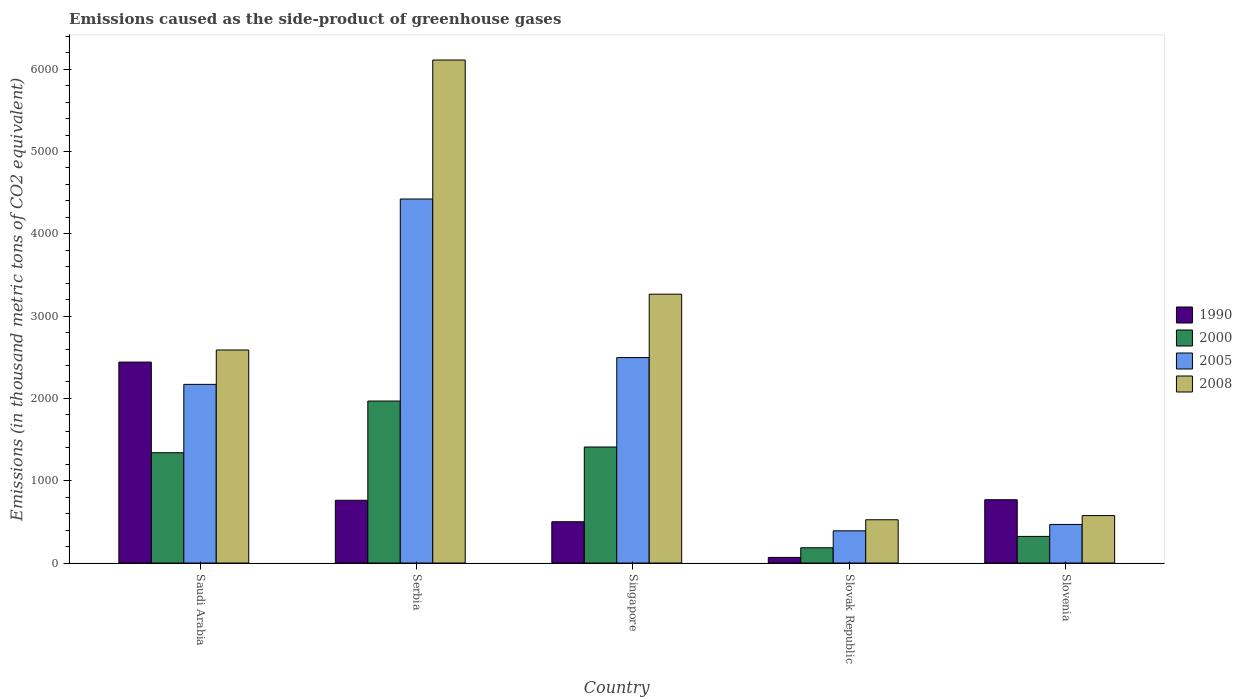How many different coloured bars are there?
Your response must be concise. 4. Are the number of bars on each tick of the X-axis equal?
Your answer should be compact. Yes. How many bars are there on the 1st tick from the left?
Your response must be concise. 4. How many bars are there on the 1st tick from the right?
Your answer should be very brief. 4. What is the label of the 2nd group of bars from the left?
Provide a succinct answer. Serbia. What is the emissions caused as the side-product of greenhouse gases in 2005 in Saudi Arabia?
Keep it short and to the point. 2170.7. Across all countries, what is the maximum emissions caused as the side-product of greenhouse gases in 2008?
Provide a short and direct response. 6111.3. Across all countries, what is the minimum emissions caused as the side-product of greenhouse gases in 2008?
Keep it short and to the point. 525.8. In which country was the emissions caused as the side-product of greenhouse gases in 2000 maximum?
Provide a short and direct response. Serbia. In which country was the emissions caused as the side-product of greenhouse gases in 1990 minimum?
Your answer should be very brief. Slovak Republic. What is the total emissions caused as the side-product of greenhouse gases in 2000 in the graph?
Offer a terse response. 5226.7. What is the difference between the emissions caused as the side-product of greenhouse gases in 2005 in Singapore and that in Slovenia?
Provide a succinct answer. 2027.5. What is the difference between the emissions caused as the side-product of greenhouse gases in 2000 in Singapore and the emissions caused as the side-product of greenhouse gases in 2005 in Serbia?
Give a very brief answer. -3013.2. What is the average emissions caused as the side-product of greenhouse gases in 2000 per country?
Offer a terse response. 1045.34. What is the difference between the emissions caused as the side-product of greenhouse gases of/in 2008 and emissions caused as the side-product of greenhouse gases of/in 1990 in Serbia?
Keep it short and to the point. 5348.9. In how many countries, is the emissions caused as the side-product of greenhouse gases in 2005 greater than 2400 thousand metric tons?
Ensure brevity in your answer.  2. What is the ratio of the emissions caused as the side-product of greenhouse gases in 2000 in Serbia to that in Singapore?
Provide a succinct answer. 1.4. Is the emissions caused as the side-product of greenhouse gases in 2000 in Saudi Arabia less than that in Serbia?
Offer a terse response. Yes. What is the difference between the highest and the second highest emissions caused as the side-product of greenhouse gases in 2000?
Provide a short and direct response. 558.5. What is the difference between the highest and the lowest emissions caused as the side-product of greenhouse gases in 2000?
Provide a short and direct response. 1782.5. What does the 2nd bar from the right in Saudi Arabia represents?
Offer a terse response. 2005. Are the values on the major ticks of Y-axis written in scientific E-notation?
Provide a short and direct response. No. Does the graph contain any zero values?
Make the answer very short. No. Where does the legend appear in the graph?
Offer a very short reply. Center right. What is the title of the graph?
Provide a succinct answer. Emissions caused as the side-product of greenhouse gases. What is the label or title of the X-axis?
Provide a short and direct response. Country. What is the label or title of the Y-axis?
Your answer should be very brief. Emissions (in thousand metric tons of CO2 equivalent). What is the Emissions (in thousand metric tons of CO2 equivalent) in 1990 in Saudi Arabia?
Provide a short and direct response. 2441.4. What is the Emissions (in thousand metric tons of CO2 equivalent) in 2000 in Saudi Arabia?
Provide a short and direct response. 1340.1. What is the Emissions (in thousand metric tons of CO2 equivalent) in 2005 in Saudi Arabia?
Offer a very short reply. 2170.7. What is the Emissions (in thousand metric tons of CO2 equivalent) in 2008 in Saudi Arabia?
Ensure brevity in your answer.  2588.3. What is the Emissions (in thousand metric tons of CO2 equivalent) of 1990 in Serbia?
Give a very brief answer. 762.4. What is the Emissions (in thousand metric tons of CO2 equivalent) in 2000 in Serbia?
Provide a succinct answer. 1968.1. What is the Emissions (in thousand metric tons of CO2 equivalent) of 2005 in Serbia?
Your response must be concise. 4422.8. What is the Emissions (in thousand metric tons of CO2 equivalent) of 2008 in Serbia?
Offer a terse response. 6111.3. What is the Emissions (in thousand metric tons of CO2 equivalent) of 1990 in Singapore?
Your answer should be compact. 501.5. What is the Emissions (in thousand metric tons of CO2 equivalent) of 2000 in Singapore?
Provide a succinct answer. 1409.6. What is the Emissions (in thousand metric tons of CO2 equivalent) of 2005 in Singapore?
Offer a very short reply. 2496.4. What is the Emissions (in thousand metric tons of CO2 equivalent) in 2008 in Singapore?
Your response must be concise. 3266.4. What is the Emissions (in thousand metric tons of CO2 equivalent) of 1990 in Slovak Republic?
Keep it short and to the point. 68.3. What is the Emissions (in thousand metric tons of CO2 equivalent) of 2000 in Slovak Republic?
Ensure brevity in your answer.  185.6. What is the Emissions (in thousand metric tons of CO2 equivalent) in 2005 in Slovak Republic?
Provide a succinct answer. 391.3. What is the Emissions (in thousand metric tons of CO2 equivalent) of 2008 in Slovak Republic?
Offer a very short reply. 525.8. What is the Emissions (in thousand metric tons of CO2 equivalent) of 1990 in Slovenia?
Your answer should be compact. 769. What is the Emissions (in thousand metric tons of CO2 equivalent) of 2000 in Slovenia?
Your answer should be compact. 323.3. What is the Emissions (in thousand metric tons of CO2 equivalent) of 2005 in Slovenia?
Provide a succinct answer. 468.9. What is the Emissions (in thousand metric tons of CO2 equivalent) of 2008 in Slovenia?
Provide a succinct answer. 576.7. Across all countries, what is the maximum Emissions (in thousand metric tons of CO2 equivalent) in 1990?
Give a very brief answer. 2441.4. Across all countries, what is the maximum Emissions (in thousand metric tons of CO2 equivalent) in 2000?
Provide a short and direct response. 1968.1. Across all countries, what is the maximum Emissions (in thousand metric tons of CO2 equivalent) of 2005?
Provide a short and direct response. 4422.8. Across all countries, what is the maximum Emissions (in thousand metric tons of CO2 equivalent) in 2008?
Your answer should be very brief. 6111.3. Across all countries, what is the minimum Emissions (in thousand metric tons of CO2 equivalent) in 1990?
Provide a short and direct response. 68.3. Across all countries, what is the minimum Emissions (in thousand metric tons of CO2 equivalent) in 2000?
Your answer should be compact. 185.6. Across all countries, what is the minimum Emissions (in thousand metric tons of CO2 equivalent) of 2005?
Give a very brief answer. 391.3. Across all countries, what is the minimum Emissions (in thousand metric tons of CO2 equivalent) of 2008?
Offer a terse response. 525.8. What is the total Emissions (in thousand metric tons of CO2 equivalent) of 1990 in the graph?
Keep it short and to the point. 4542.6. What is the total Emissions (in thousand metric tons of CO2 equivalent) in 2000 in the graph?
Keep it short and to the point. 5226.7. What is the total Emissions (in thousand metric tons of CO2 equivalent) of 2005 in the graph?
Provide a short and direct response. 9950.1. What is the total Emissions (in thousand metric tons of CO2 equivalent) of 2008 in the graph?
Keep it short and to the point. 1.31e+04. What is the difference between the Emissions (in thousand metric tons of CO2 equivalent) in 1990 in Saudi Arabia and that in Serbia?
Ensure brevity in your answer.  1679. What is the difference between the Emissions (in thousand metric tons of CO2 equivalent) in 2000 in Saudi Arabia and that in Serbia?
Ensure brevity in your answer.  -628. What is the difference between the Emissions (in thousand metric tons of CO2 equivalent) of 2005 in Saudi Arabia and that in Serbia?
Give a very brief answer. -2252.1. What is the difference between the Emissions (in thousand metric tons of CO2 equivalent) of 2008 in Saudi Arabia and that in Serbia?
Make the answer very short. -3523. What is the difference between the Emissions (in thousand metric tons of CO2 equivalent) of 1990 in Saudi Arabia and that in Singapore?
Your answer should be very brief. 1939.9. What is the difference between the Emissions (in thousand metric tons of CO2 equivalent) of 2000 in Saudi Arabia and that in Singapore?
Offer a terse response. -69.5. What is the difference between the Emissions (in thousand metric tons of CO2 equivalent) of 2005 in Saudi Arabia and that in Singapore?
Provide a succinct answer. -325.7. What is the difference between the Emissions (in thousand metric tons of CO2 equivalent) of 2008 in Saudi Arabia and that in Singapore?
Your response must be concise. -678.1. What is the difference between the Emissions (in thousand metric tons of CO2 equivalent) in 1990 in Saudi Arabia and that in Slovak Republic?
Ensure brevity in your answer.  2373.1. What is the difference between the Emissions (in thousand metric tons of CO2 equivalent) in 2000 in Saudi Arabia and that in Slovak Republic?
Your answer should be compact. 1154.5. What is the difference between the Emissions (in thousand metric tons of CO2 equivalent) in 2005 in Saudi Arabia and that in Slovak Republic?
Your answer should be compact. 1779.4. What is the difference between the Emissions (in thousand metric tons of CO2 equivalent) of 2008 in Saudi Arabia and that in Slovak Republic?
Provide a succinct answer. 2062.5. What is the difference between the Emissions (in thousand metric tons of CO2 equivalent) in 1990 in Saudi Arabia and that in Slovenia?
Make the answer very short. 1672.4. What is the difference between the Emissions (in thousand metric tons of CO2 equivalent) of 2000 in Saudi Arabia and that in Slovenia?
Ensure brevity in your answer.  1016.8. What is the difference between the Emissions (in thousand metric tons of CO2 equivalent) of 2005 in Saudi Arabia and that in Slovenia?
Your answer should be very brief. 1701.8. What is the difference between the Emissions (in thousand metric tons of CO2 equivalent) of 2008 in Saudi Arabia and that in Slovenia?
Offer a very short reply. 2011.6. What is the difference between the Emissions (in thousand metric tons of CO2 equivalent) in 1990 in Serbia and that in Singapore?
Your answer should be very brief. 260.9. What is the difference between the Emissions (in thousand metric tons of CO2 equivalent) in 2000 in Serbia and that in Singapore?
Offer a terse response. 558.5. What is the difference between the Emissions (in thousand metric tons of CO2 equivalent) in 2005 in Serbia and that in Singapore?
Your answer should be compact. 1926.4. What is the difference between the Emissions (in thousand metric tons of CO2 equivalent) in 2008 in Serbia and that in Singapore?
Provide a succinct answer. 2844.9. What is the difference between the Emissions (in thousand metric tons of CO2 equivalent) in 1990 in Serbia and that in Slovak Republic?
Your answer should be very brief. 694.1. What is the difference between the Emissions (in thousand metric tons of CO2 equivalent) in 2000 in Serbia and that in Slovak Republic?
Give a very brief answer. 1782.5. What is the difference between the Emissions (in thousand metric tons of CO2 equivalent) in 2005 in Serbia and that in Slovak Republic?
Ensure brevity in your answer.  4031.5. What is the difference between the Emissions (in thousand metric tons of CO2 equivalent) in 2008 in Serbia and that in Slovak Republic?
Give a very brief answer. 5585.5. What is the difference between the Emissions (in thousand metric tons of CO2 equivalent) in 2000 in Serbia and that in Slovenia?
Provide a short and direct response. 1644.8. What is the difference between the Emissions (in thousand metric tons of CO2 equivalent) in 2005 in Serbia and that in Slovenia?
Your answer should be very brief. 3953.9. What is the difference between the Emissions (in thousand metric tons of CO2 equivalent) in 2008 in Serbia and that in Slovenia?
Give a very brief answer. 5534.6. What is the difference between the Emissions (in thousand metric tons of CO2 equivalent) of 1990 in Singapore and that in Slovak Republic?
Your answer should be compact. 433.2. What is the difference between the Emissions (in thousand metric tons of CO2 equivalent) in 2000 in Singapore and that in Slovak Republic?
Your response must be concise. 1224. What is the difference between the Emissions (in thousand metric tons of CO2 equivalent) of 2005 in Singapore and that in Slovak Republic?
Keep it short and to the point. 2105.1. What is the difference between the Emissions (in thousand metric tons of CO2 equivalent) in 2008 in Singapore and that in Slovak Republic?
Provide a succinct answer. 2740.6. What is the difference between the Emissions (in thousand metric tons of CO2 equivalent) of 1990 in Singapore and that in Slovenia?
Keep it short and to the point. -267.5. What is the difference between the Emissions (in thousand metric tons of CO2 equivalent) of 2000 in Singapore and that in Slovenia?
Your response must be concise. 1086.3. What is the difference between the Emissions (in thousand metric tons of CO2 equivalent) in 2005 in Singapore and that in Slovenia?
Keep it short and to the point. 2027.5. What is the difference between the Emissions (in thousand metric tons of CO2 equivalent) in 2008 in Singapore and that in Slovenia?
Offer a terse response. 2689.7. What is the difference between the Emissions (in thousand metric tons of CO2 equivalent) in 1990 in Slovak Republic and that in Slovenia?
Give a very brief answer. -700.7. What is the difference between the Emissions (in thousand metric tons of CO2 equivalent) of 2000 in Slovak Republic and that in Slovenia?
Your answer should be very brief. -137.7. What is the difference between the Emissions (in thousand metric tons of CO2 equivalent) in 2005 in Slovak Republic and that in Slovenia?
Provide a succinct answer. -77.6. What is the difference between the Emissions (in thousand metric tons of CO2 equivalent) of 2008 in Slovak Republic and that in Slovenia?
Give a very brief answer. -50.9. What is the difference between the Emissions (in thousand metric tons of CO2 equivalent) of 1990 in Saudi Arabia and the Emissions (in thousand metric tons of CO2 equivalent) of 2000 in Serbia?
Your answer should be compact. 473.3. What is the difference between the Emissions (in thousand metric tons of CO2 equivalent) in 1990 in Saudi Arabia and the Emissions (in thousand metric tons of CO2 equivalent) in 2005 in Serbia?
Your answer should be very brief. -1981.4. What is the difference between the Emissions (in thousand metric tons of CO2 equivalent) in 1990 in Saudi Arabia and the Emissions (in thousand metric tons of CO2 equivalent) in 2008 in Serbia?
Your response must be concise. -3669.9. What is the difference between the Emissions (in thousand metric tons of CO2 equivalent) of 2000 in Saudi Arabia and the Emissions (in thousand metric tons of CO2 equivalent) of 2005 in Serbia?
Offer a terse response. -3082.7. What is the difference between the Emissions (in thousand metric tons of CO2 equivalent) of 2000 in Saudi Arabia and the Emissions (in thousand metric tons of CO2 equivalent) of 2008 in Serbia?
Your answer should be compact. -4771.2. What is the difference between the Emissions (in thousand metric tons of CO2 equivalent) of 2005 in Saudi Arabia and the Emissions (in thousand metric tons of CO2 equivalent) of 2008 in Serbia?
Provide a succinct answer. -3940.6. What is the difference between the Emissions (in thousand metric tons of CO2 equivalent) in 1990 in Saudi Arabia and the Emissions (in thousand metric tons of CO2 equivalent) in 2000 in Singapore?
Make the answer very short. 1031.8. What is the difference between the Emissions (in thousand metric tons of CO2 equivalent) of 1990 in Saudi Arabia and the Emissions (in thousand metric tons of CO2 equivalent) of 2005 in Singapore?
Offer a very short reply. -55. What is the difference between the Emissions (in thousand metric tons of CO2 equivalent) in 1990 in Saudi Arabia and the Emissions (in thousand metric tons of CO2 equivalent) in 2008 in Singapore?
Offer a terse response. -825. What is the difference between the Emissions (in thousand metric tons of CO2 equivalent) in 2000 in Saudi Arabia and the Emissions (in thousand metric tons of CO2 equivalent) in 2005 in Singapore?
Provide a succinct answer. -1156.3. What is the difference between the Emissions (in thousand metric tons of CO2 equivalent) in 2000 in Saudi Arabia and the Emissions (in thousand metric tons of CO2 equivalent) in 2008 in Singapore?
Give a very brief answer. -1926.3. What is the difference between the Emissions (in thousand metric tons of CO2 equivalent) of 2005 in Saudi Arabia and the Emissions (in thousand metric tons of CO2 equivalent) of 2008 in Singapore?
Ensure brevity in your answer.  -1095.7. What is the difference between the Emissions (in thousand metric tons of CO2 equivalent) of 1990 in Saudi Arabia and the Emissions (in thousand metric tons of CO2 equivalent) of 2000 in Slovak Republic?
Make the answer very short. 2255.8. What is the difference between the Emissions (in thousand metric tons of CO2 equivalent) of 1990 in Saudi Arabia and the Emissions (in thousand metric tons of CO2 equivalent) of 2005 in Slovak Republic?
Offer a very short reply. 2050.1. What is the difference between the Emissions (in thousand metric tons of CO2 equivalent) in 1990 in Saudi Arabia and the Emissions (in thousand metric tons of CO2 equivalent) in 2008 in Slovak Republic?
Offer a very short reply. 1915.6. What is the difference between the Emissions (in thousand metric tons of CO2 equivalent) of 2000 in Saudi Arabia and the Emissions (in thousand metric tons of CO2 equivalent) of 2005 in Slovak Republic?
Your answer should be compact. 948.8. What is the difference between the Emissions (in thousand metric tons of CO2 equivalent) in 2000 in Saudi Arabia and the Emissions (in thousand metric tons of CO2 equivalent) in 2008 in Slovak Republic?
Offer a very short reply. 814.3. What is the difference between the Emissions (in thousand metric tons of CO2 equivalent) of 2005 in Saudi Arabia and the Emissions (in thousand metric tons of CO2 equivalent) of 2008 in Slovak Republic?
Give a very brief answer. 1644.9. What is the difference between the Emissions (in thousand metric tons of CO2 equivalent) of 1990 in Saudi Arabia and the Emissions (in thousand metric tons of CO2 equivalent) of 2000 in Slovenia?
Offer a terse response. 2118.1. What is the difference between the Emissions (in thousand metric tons of CO2 equivalent) of 1990 in Saudi Arabia and the Emissions (in thousand metric tons of CO2 equivalent) of 2005 in Slovenia?
Keep it short and to the point. 1972.5. What is the difference between the Emissions (in thousand metric tons of CO2 equivalent) of 1990 in Saudi Arabia and the Emissions (in thousand metric tons of CO2 equivalent) of 2008 in Slovenia?
Make the answer very short. 1864.7. What is the difference between the Emissions (in thousand metric tons of CO2 equivalent) of 2000 in Saudi Arabia and the Emissions (in thousand metric tons of CO2 equivalent) of 2005 in Slovenia?
Make the answer very short. 871.2. What is the difference between the Emissions (in thousand metric tons of CO2 equivalent) in 2000 in Saudi Arabia and the Emissions (in thousand metric tons of CO2 equivalent) in 2008 in Slovenia?
Your answer should be compact. 763.4. What is the difference between the Emissions (in thousand metric tons of CO2 equivalent) of 2005 in Saudi Arabia and the Emissions (in thousand metric tons of CO2 equivalent) of 2008 in Slovenia?
Offer a terse response. 1594. What is the difference between the Emissions (in thousand metric tons of CO2 equivalent) of 1990 in Serbia and the Emissions (in thousand metric tons of CO2 equivalent) of 2000 in Singapore?
Offer a very short reply. -647.2. What is the difference between the Emissions (in thousand metric tons of CO2 equivalent) in 1990 in Serbia and the Emissions (in thousand metric tons of CO2 equivalent) in 2005 in Singapore?
Offer a very short reply. -1734. What is the difference between the Emissions (in thousand metric tons of CO2 equivalent) of 1990 in Serbia and the Emissions (in thousand metric tons of CO2 equivalent) of 2008 in Singapore?
Provide a short and direct response. -2504. What is the difference between the Emissions (in thousand metric tons of CO2 equivalent) in 2000 in Serbia and the Emissions (in thousand metric tons of CO2 equivalent) in 2005 in Singapore?
Provide a succinct answer. -528.3. What is the difference between the Emissions (in thousand metric tons of CO2 equivalent) of 2000 in Serbia and the Emissions (in thousand metric tons of CO2 equivalent) of 2008 in Singapore?
Your answer should be very brief. -1298.3. What is the difference between the Emissions (in thousand metric tons of CO2 equivalent) in 2005 in Serbia and the Emissions (in thousand metric tons of CO2 equivalent) in 2008 in Singapore?
Your answer should be compact. 1156.4. What is the difference between the Emissions (in thousand metric tons of CO2 equivalent) in 1990 in Serbia and the Emissions (in thousand metric tons of CO2 equivalent) in 2000 in Slovak Republic?
Offer a very short reply. 576.8. What is the difference between the Emissions (in thousand metric tons of CO2 equivalent) of 1990 in Serbia and the Emissions (in thousand metric tons of CO2 equivalent) of 2005 in Slovak Republic?
Make the answer very short. 371.1. What is the difference between the Emissions (in thousand metric tons of CO2 equivalent) in 1990 in Serbia and the Emissions (in thousand metric tons of CO2 equivalent) in 2008 in Slovak Republic?
Offer a very short reply. 236.6. What is the difference between the Emissions (in thousand metric tons of CO2 equivalent) of 2000 in Serbia and the Emissions (in thousand metric tons of CO2 equivalent) of 2005 in Slovak Republic?
Your answer should be very brief. 1576.8. What is the difference between the Emissions (in thousand metric tons of CO2 equivalent) in 2000 in Serbia and the Emissions (in thousand metric tons of CO2 equivalent) in 2008 in Slovak Republic?
Provide a succinct answer. 1442.3. What is the difference between the Emissions (in thousand metric tons of CO2 equivalent) in 2005 in Serbia and the Emissions (in thousand metric tons of CO2 equivalent) in 2008 in Slovak Republic?
Keep it short and to the point. 3897. What is the difference between the Emissions (in thousand metric tons of CO2 equivalent) of 1990 in Serbia and the Emissions (in thousand metric tons of CO2 equivalent) of 2000 in Slovenia?
Offer a terse response. 439.1. What is the difference between the Emissions (in thousand metric tons of CO2 equivalent) of 1990 in Serbia and the Emissions (in thousand metric tons of CO2 equivalent) of 2005 in Slovenia?
Your answer should be very brief. 293.5. What is the difference between the Emissions (in thousand metric tons of CO2 equivalent) in 1990 in Serbia and the Emissions (in thousand metric tons of CO2 equivalent) in 2008 in Slovenia?
Your answer should be very brief. 185.7. What is the difference between the Emissions (in thousand metric tons of CO2 equivalent) in 2000 in Serbia and the Emissions (in thousand metric tons of CO2 equivalent) in 2005 in Slovenia?
Ensure brevity in your answer.  1499.2. What is the difference between the Emissions (in thousand metric tons of CO2 equivalent) in 2000 in Serbia and the Emissions (in thousand metric tons of CO2 equivalent) in 2008 in Slovenia?
Offer a very short reply. 1391.4. What is the difference between the Emissions (in thousand metric tons of CO2 equivalent) of 2005 in Serbia and the Emissions (in thousand metric tons of CO2 equivalent) of 2008 in Slovenia?
Make the answer very short. 3846.1. What is the difference between the Emissions (in thousand metric tons of CO2 equivalent) of 1990 in Singapore and the Emissions (in thousand metric tons of CO2 equivalent) of 2000 in Slovak Republic?
Keep it short and to the point. 315.9. What is the difference between the Emissions (in thousand metric tons of CO2 equivalent) in 1990 in Singapore and the Emissions (in thousand metric tons of CO2 equivalent) in 2005 in Slovak Republic?
Your answer should be very brief. 110.2. What is the difference between the Emissions (in thousand metric tons of CO2 equivalent) of 1990 in Singapore and the Emissions (in thousand metric tons of CO2 equivalent) of 2008 in Slovak Republic?
Provide a short and direct response. -24.3. What is the difference between the Emissions (in thousand metric tons of CO2 equivalent) of 2000 in Singapore and the Emissions (in thousand metric tons of CO2 equivalent) of 2005 in Slovak Republic?
Ensure brevity in your answer.  1018.3. What is the difference between the Emissions (in thousand metric tons of CO2 equivalent) in 2000 in Singapore and the Emissions (in thousand metric tons of CO2 equivalent) in 2008 in Slovak Republic?
Offer a very short reply. 883.8. What is the difference between the Emissions (in thousand metric tons of CO2 equivalent) in 2005 in Singapore and the Emissions (in thousand metric tons of CO2 equivalent) in 2008 in Slovak Republic?
Your response must be concise. 1970.6. What is the difference between the Emissions (in thousand metric tons of CO2 equivalent) of 1990 in Singapore and the Emissions (in thousand metric tons of CO2 equivalent) of 2000 in Slovenia?
Give a very brief answer. 178.2. What is the difference between the Emissions (in thousand metric tons of CO2 equivalent) of 1990 in Singapore and the Emissions (in thousand metric tons of CO2 equivalent) of 2005 in Slovenia?
Offer a very short reply. 32.6. What is the difference between the Emissions (in thousand metric tons of CO2 equivalent) in 1990 in Singapore and the Emissions (in thousand metric tons of CO2 equivalent) in 2008 in Slovenia?
Make the answer very short. -75.2. What is the difference between the Emissions (in thousand metric tons of CO2 equivalent) of 2000 in Singapore and the Emissions (in thousand metric tons of CO2 equivalent) of 2005 in Slovenia?
Your answer should be very brief. 940.7. What is the difference between the Emissions (in thousand metric tons of CO2 equivalent) in 2000 in Singapore and the Emissions (in thousand metric tons of CO2 equivalent) in 2008 in Slovenia?
Keep it short and to the point. 832.9. What is the difference between the Emissions (in thousand metric tons of CO2 equivalent) of 2005 in Singapore and the Emissions (in thousand metric tons of CO2 equivalent) of 2008 in Slovenia?
Offer a very short reply. 1919.7. What is the difference between the Emissions (in thousand metric tons of CO2 equivalent) in 1990 in Slovak Republic and the Emissions (in thousand metric tons of CO2 equivalent) in 2000 in Slovenia?
Give a very brief answer. -255. What is the difference between the Emissions (in thousand metric tons of CO2 equivalent) in 1990 in Slovak Republic and the Emissions (in thousand metric tons of CO2 equivalent) in 2005 in Slovenia?
Your response must be concise. -400.6. What is the difference between the Emissions (in thousand metric tons of CO2 equivalent) in 1990 in Slovak Republic and the Emissions (in thousand metric tons of CO2 equivalent) in 2008 in Slovenia?
Ensure brevity in your answer.  -508.4. What is the difference between the Emissions (in thousand metric tons of CO2 equivalent) of 2000 in Slovak Republic and the Emissions (in thousand metric tons of CO2 equivalent) of 2005 in Slovenia?
Your answer should be very brief. -283.3. What is the difference between the Emissions (in thousand metric tons of CO2 equivalent) in 2000 in Slovak Republic and the Emissions (in thousand metric tons of CO2 equivalent) in 2008 in Slovenia?
Your answer should be very brief. -391.1. What is the difference between the Emissions (in thousand metric tons of CO2 equivalent) in 2005 in Slovak Republic and the Emissions (in thousand metric tons of CO2 equivalent) in 2008 in Slovenia?
Ensure brevity in your answer.  -185.4. What is the average Emissions (in thousand metric tons of CO2 equivalent) of 1990 per country?
Your answer should be compact. 908.52. What is the average Emissions (in thousand metric tons of CO2 equivalent) in 2000 per country?
Your answer should be compact. 1045.34. What is the average Emissions (in thousand metric tons of CO2 equivalent) of 2005 per country?
Provide a short and direct response. 1990.02. What is the average Emissions (in thousand metric tons of CO2 equivalent) in 2008 per country?
Your response must be concise. 2613.7. What is the difference between the Emissions (in thousand metric tons of CO2 equivalent) of 1990 and Emissions (in thousand metric tons of CO2 equivalent) of 2000 in Saudi Arabia?
Give a very brief answer. 1101.3. What is the difference between the Emissions (in thousand metric tons of CO2 equivalent) in 1990 and Emissions (in thousand metric tons of CO2 equivalent) in 2005 in Saudi Arabia?
Provide a succinct answer. 270.7. What is the difference between the Emissions (in thousand metric tons of CO2 equivalent) of 1990 and Emissions (in thousand metric tons of CO2 equivalent) of 2008 in Saudi Arabia?
Make the answer very short. -146.9. What is the difference between the Emissions (in thousand metric tons of CO2 equivalent) in 2000 and Emissions (in thousand metric tons of CO2 equivalent) in 2005 in Saudi Arabia?
Your response must be concise. -830.6. What is the difference between the Emissions (in thousand metric tons of CO2 equivalent) of 2000 and Emissions (in thousand metric tons of CO2 equivalent) of 2008 in Saudi Arabia?
Ensure brevity in your answer.  -1248.2. What is the difference between the Emissions (in thousand metric tons of CO2 equivalent) in 2005 and Emissions (in thousand metric tons of CO2 equivalent) in 2008 in Saudi Arabia?
Make the answer very short. -417.6. What is the difference between the Emissions (in thousand metric tons of CO2 equivalent) in 1990 and Emissions (in thousand metric tons of CO2 equivalent) in 2000 in Serbia?
Your answer should be very brief. -1205.7. What is the difference between the Emissions (in thousand metric tons of CO2 equivalent) in 1990 and Emissions (in thousand metric tons of CO2 equivalent) in 2005 in Serbia?
Provide a short and direct response. -3660.4. What is the difference between the Emissions (in thousand metric tons of CO2 equivalent) in 1990 and Emissions (in thousand metric tons of CO2 equivalent) in 2008 in Serbia?
Ensure brevity in your answer.  -5348.9. What is the difference between the Emissions (in thousand metric tons of CO2 equivalent) in 2000 and Emissions (in thousand metric tons of CO2 equivalent) in 2005 in Serbia?
Ensure brevity in your answer.  -2454.7. What is the difference between the Emissions (in thousand metric tons of CO2 equivalent) in 2000 and Emissions (in thousand metric tons of CO2 equivalent) in 2008 in Serbia?
Your response must be concise. -4143.2. What is the difference between the Emissions (in thousand metric tons of CO2 equivalent) of 2005 and Emissions (in thousand metric tons of CO2 equivalent) of 2008 in Serbia?
Your response must be concise. -1688.5. What is the difference between the Emissions (in thousand metric tons of CO2 equivalent) in 1990 and Emissions (in thousand metric tons of CO2 equivalent) in 2000 in Singapore?
Offer a very short reply. -908.1. What is the difference between the Emissions (in thousand metric tons of CO2 equivalent) of 1990 and Emissions (in thousand metric tons of CO2 equivalent) of 2005 in Singapore?
Offer a very short reply. -1994.9. What is the difference between the Emissions (in thousand metric tons of CO2 equivalent) of 1990 and Emissions (in thousand metric tons of CO2 equivalent) of 2008 in Singapore?
Provide a succinct answer. -2764.9. What is the difference between the Emissions (in thousand metric tons of CO2 equivalent) in 2000 and Emissions (in thousand metric tons of CO2 equivalent) in 2005 in Singapore?
Give a very brief answer. -1086.8. What is the difference between the Emissions (in thousand metric tons of CO2 equivalent) of 2000 and Emissions (in thousand metric tons of CO2 equivalent) of 2008 in Singapore?
Offer a very short reply. -1856.8. What is the difference between the Emissions (in thousand metric tons of CO2 equivalent) of 2005 and Emissions (in thousand metric tons of CO2 equivalent) of 2008 in Singapore?
Your answer should be very brief. -770. What is the difference between the Emissions (in thousand metric tons of CO2 equivalent) of 1990 and Emissions (in thousand metric tons of CO2 equivalent) of 2000 in Slovak Republic?
Your answer should be compact. -117.3. What is the difference between the Emissions (in thousand metric tons of CO2 equivalent) in 1990 and Emissions (in thousand metric tons of CO2 equivalent) in 2005 in Slovak Republic?
Give a very brief answer. -323. What is the difference between the Emissions (in thousand metric tons of CO2 equivalent) of 1990 and Emissions (in thousand metric tons of CO2 equivalent) of 2008 in Slovak Republic?
Your answer should be compact. -457.5. What is the difference between the Emissions (in thousand metric tons of CO2 equivalent) in 2000 and Emissions (in thousand metric tons of CO2 equivalent) in 2005 in Slovak Republic?
Give a very brief answer. -205.7. What is the difference between the Emissions (in thousand metric tons of CO2 equivalent) in 2000 and Emissions (in thousand metric tons of CO2 equivalent) in 2008 in Slovak Republic?
Offer a very short reply. -340.2. What is the difference between the Emissions (in thousand metric tons of CO2 equivalent) in 2005 and Emissions (in thousand metric tons of CO2 equivalent) in 2008 in Slovak Republic?
Provide a short and direct response. -134.5. What is the difference between the Emissions (in thousand metric tons of CO2 equivalent) in 1990 and Emissions (in thousand metric tons of CO2 equivalent) in 2000 in Slovenia?
Provide a short and direct response. 445.7. What is the difference between the Emissions (in thousand metric tons of CO2 equivalent) of 1990 and Emissions (in thousand metric tons of CO2 equivalent) of 2005 in Slovenia?
Your answer should be compact. 300.1. What is the difference between the Emissions (in thousand metric tons of CO2 equivalent) in 1990 and Emissions (in thousand metric tons of CO2 equivalent) in 2008 in Slovenia?
Keep it short and to the point. 192.3. What is the difference between the Emissions (in thousand metric tons of CO2 equivalent) of 2000 and Emissions (in thousand metric tons of CO2 equivalent) of 2005 in Slovenia?
Give a very brief answer. -145.6. What is the difference between the Emissions (in thousand metric tons of CO2 equivalent) in 2000 and Emissions (in thousand metric tons of CO2 equivalent) in 2008 in Slovenia?
Give a very brief answer. -253.4. What is the difference between the Emissions (in thousand metric tons of CO2 equivalent) of 2005 and Emissions (in thousand metric tons of CO2 equivalent) of 2008 in Slovenia?
Ensure brevity in your answer.  -107.8. What is the ratio of the Emissions (in thousand metric tons of CO2 equivalent) of 1990 in Saudi Arabia to that in Serbia?
Provide a succinct answer. 3.2. What is the ratio of the Emissions (in thousand metric tons of CO2 equivalent) of 2000 in Saudi Arabia to that in Serbia?
Ensure brevity in your answer.  0.68. What is the ratio of the Emissions (in thousand metric tons of CO2 equivalent) in 2005 in Saudi Arabia to that in Serbia?
Make the answer very short. 0.49. What is the ratio of the Emissions (in thousand metric tons of CO2 equivalent) of 2008 in Saudi Arabia to that in Serbia?
Provide a short and direct response. 0.42. What is the ratio of the Emissions (in thousand metric tons of CO2 equivalent) in 1990 in Saudi Arabia to that in Singapore?
Keep it short and to the point. 4.87. What is the ratio of the Emissions (in thousand metric tons of CO2 equivalent) in 2000 in Saudi Arabia to that in Singapore?
Make the answer very short. 0.95. What is the ratio of the Emissions (in thousand metric tons of CO2 equivalent) of 2005 in Saudi Arabia to that in Singapore?
Provide a short and direct response. 0.87. What is the ratio of the Emissions (in thousand metric tons of CO2 equivalent) in 2008 in Saudi Arabia to that in Singapore?
Your answer should be very brief. 0.79. What is the ratio of the Emissions (in thousand metric tons of CO2 equivalent) in 1990 in Saudi Arabia to that in Slovak Republic?
Your response must be concise. 35.75. What is the ratio of the Emissions (in thousand metric tons of CO2 equivalent) of 2000 in Saudi Arabia to that in Slovak Republic?
Give a very brief answer. 7.22. What is the ratio of the Emissions (in thousand metric tons of CO2 equivalent) of 2005 in Saudi Arabia to that in Slovak Republic?
Your answer should be compact. 5.55. What is the ratio of the Emissions (in thousand metric tons of CO2 equivalent) in 2008 in Saudi Arabia to that in Slovak Republic?
Your answer should be compact. 4.92. What is the ratio of the Emissions (in thousand metric tons of CO2 equivalent) of 1990 in Saudi Arabia to that in Slovenia?
Provide a succinct answer. 3.17. What is the ratio of the Emissions (in thousand metric tons of CO2 equivalent) of 2000 in Saudi Arabia to that in Slovenia?
Your answer should be very brief. 4.15. What is the ratio of the Emissions (in thousand metric tons of CO2 equivalent) in 2005 in Saudi Arabia to that in Slovenia?
Provide a short and direct response. 4.63. What is the ratio of the Emissions (in thousand metric tons of CO2 equivalent) of 2008 in Saudi Arabia to that in Slovenia?
Provide a succinct answer. 4.49. What is the ratio of the Emissions (in thousand metric tons of CO2 equivalent) in 1990 in Serbia to that in Singapore?
Ensure brevity in your answer.  1.52. What is the ratio of the Emissions (in thousand metric tons of CO2 equivalent) of 2000 in Serbia to that in Singapore?
Keep it short and to the point. 1.4. What is the ratio of the Emissions (in thousand metric tons of CO2 equivalent) of 2005 in Serbia to that in Singapore?
Ensure brevity in your answer.  1.77. What is the ratio of the Emissions (in thousand metric tons of CO2 equivalent) in 2008 in Serbia to that in Singapore?
Offer a very short reply. 1.87. What is the ratio of the Emissions (in thousand metric tons of CO2 equivalent) of 1990 in Serbia to that in Slovak Republic?
Make the answer very short. 11.16. What is the ratio of the Emissions (in thousand metric tons of CO2 equivalent) of 2000 in Serbia to that in Slovak Republic?
Your answer should be very brief. 10.6. What is the ratio of the Emissions (in thousand metric tons of CO2 equivalent) of 2005 in Serbia to that in Slovak Republic?
Provide a succinct answer. 11.3. What is the ratio of the Emissions (in thousand metric tons of CO2 equivalent) in 2008 in Serbia to that in Slovak Republic?
Offer a terse response. 11.62. What is the ratio of the Emissions (in thousand metric tons of CO2 equivalent) in 2000 in Serbia to that in Slovenia?
Make the answer very short. 6.09. What is the ratio of the Emissions (in thousand metric tons of CO2 equivalent) in 2005 in Serbia to that in Slovenia?
Ensure brevity in your answer.  9.43. What is the ratio of the Emissions (in thousand metric tons of CO2 equivalent) in 2008 in Serbia to that in Slovenia?
Provide a short and direct response. 10.6. What is the ratio of the Emissions (in thousand metric tons of CO2 equivalent) in 1990 in Singapore to that in Slovak Republic?
Your answer should be very brief. 7.34. What is the ratio of the Emissions (in thousand metric tons of CO2 equivalent) of 2000 in Singapore to that in Slovak Republic?
Keep it short and to the point. 7.59. What is the ratio of the Emissions (in thousand metric tons of CO2 equivalent) of 2005 in Singapore to that in Slovak Republic?
Give a very brief answer. 6.38. What is the ratio of the Emissions (in thousand metric tons of CO2 equivalent) in 2008 in Singapore to that in Slovak Republic?
Keep it short and to the point. 6.21. What is the ratio of the Emissions (in thousand metric tons of CO2 equivalent) of 1990 in Singapore to that in Slovenia?
Your answer should be compact. 0.65. What is the ratio of the Emissions (in thousand metric tons of CO2 equivalent) of 2000 in Singapore to that in Slovenia?
Your response must be concise. 4.36. What is the ratio of the Emissions (in thousand metric tons of CO2 equivalent) of 2005 in Singapore to that in Slovenia?
Offer a very short reply. 5.32. What is the ratio of the Emissions (in thousand metric tons of CO2 equivalent) in 2008 in Singapore to that in Slovenia?
Your response must be concise. 5.66. What is the ratio of the Emissions (in thousand metric tons of CO2 equivalent) of 1990 in Slovak Republic to that in Slovenia?
Give a very brief answer. 0.09. What is the ratio of the Emissions (in thousand metric tons of CO2 equivalent) in 2000 in Slovak Republic to that in Slovenia?
Give a very brief answer. 0.57. What is the ratio of the Emissions (in thousand metric tons of CO2 equivalent) of 2005 in Slovak Republic to that in Slovenia?
Provide a short and direct response. 0.83. What is the ratio of the Emissions (in thousand metric tons of CO2 equivalent) in 2008 in Slovak Republic to that in Slovenia?
Provide a succinct answer. 0.91. What is the difference between the highest and the second highest Emissions (in thousand metric tons of CO2 equivalent) of 1990?
Your response must be concise. 1672.4. What is the difference between the highest and the second highest Emissions (in thousand metric tons of CO2 equivalent) of 2000?
Give a very brief answer. 558.5. What is the difference between the highest and the second highest Emissions (in thousand metric tons of CO2 equivalent) of 2005?
Make the answer very short. 1926.4. What is the difference between the highest and the second highest Emissions (in thousand metric tons of CO2 equivalent) of 2008?
Make the answer very short. 2844.9. What is the difference between the highest and the lowest Emissions (in thousand metric tons of CO2 equivalent) in 1990?
Give a very brief answer. 2373.1. What is the difference between the highest and the lowest Emissions (in thousand metric tons of CO2 equivalent) in 2000?
Provide a succinct answer. 1782.5. What is the difference between the highest and the lowest Emissions (in thousand metric tons of CO2 equivalent) in 2005?
Your answer should be compact. 4031.5. What is the difference between the highest and the lowest Emissions (in thousand metric tons of CO2 equivalent) in 2008?
Provide a succinct answer. 5585.5. 